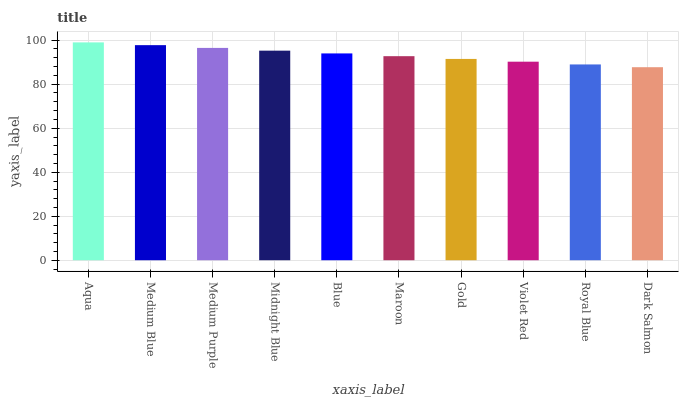Is Dark Salmon the minimum?
Answer yes or no. Yes. Is Aqua the maximum?
Answer yes or no. Yes. Is Medium Blue the minimum?
Answer yes or no. No. Is Medium Blue the maximum?
Answer yes or no. No. Is Aqua greater than Medium Blue?
Answer yes or no. Yes. Is Medium Blue less than Aqua?
Answer yes or no. Yes. Is Medium Blue greater than Aqua?
Answer yes or no. No. Is Aqua less than Medium Blue?
Answer yes or no. No. Is Blue the high median?
Answer yes or no. Yes. Is Maroon the low median?
Answer yes or no. Yes. Is Maroon the high median?
Answer yes or no. No. Is Medium Blue the low median?
Answer yes or no. No. 